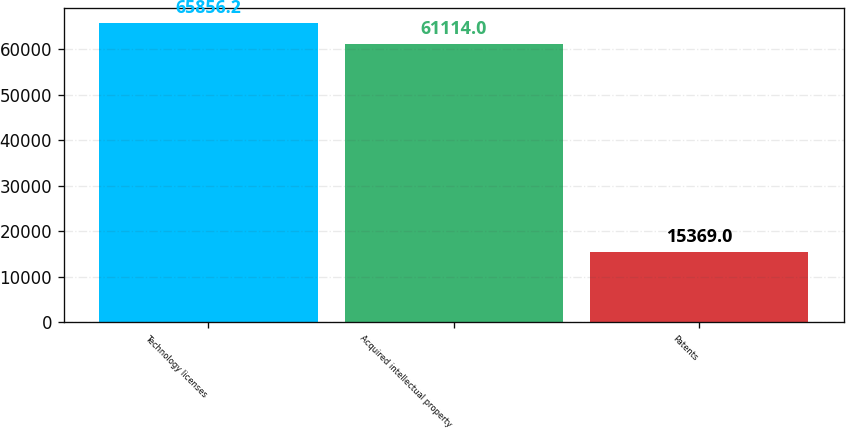<chart> <loc_0><loc_0><loc_500><loc_500><bar_chart><fcel>Technology licenses<fcel>Acquired intellectual property<fcel>Patents<nl><fcel>65856.2<fcel>61114<fcel>15369<nl></chart> 